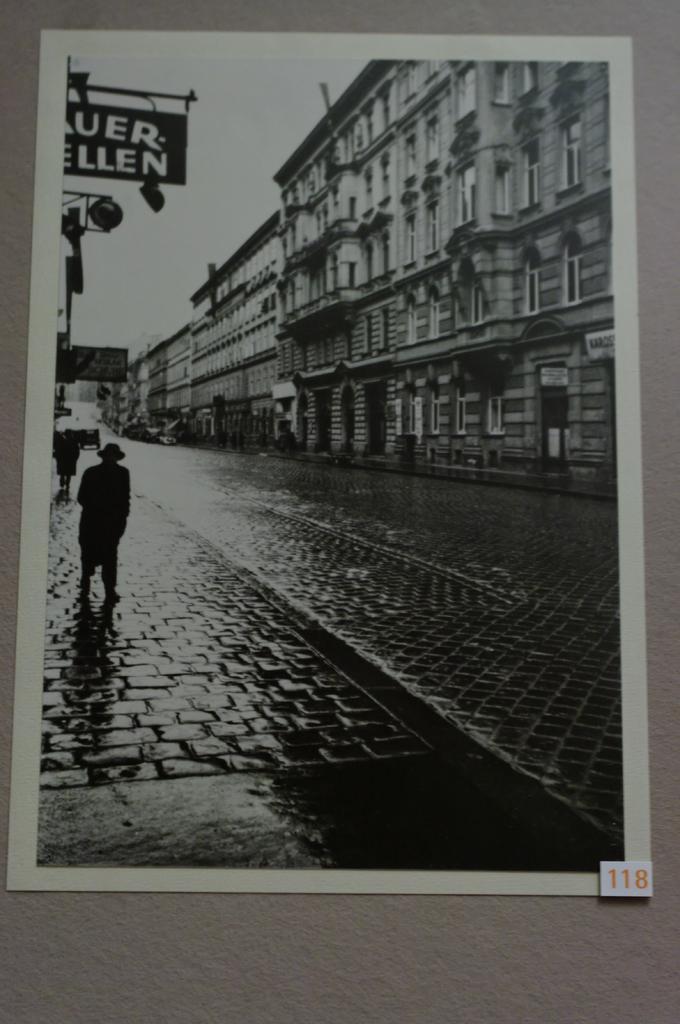Can you describe this image briefly? In this image I can see people are standing on the road. Here I can see buildings and a board which has something written on it. I can also see the sky. This is a photo which is black and white in color. 